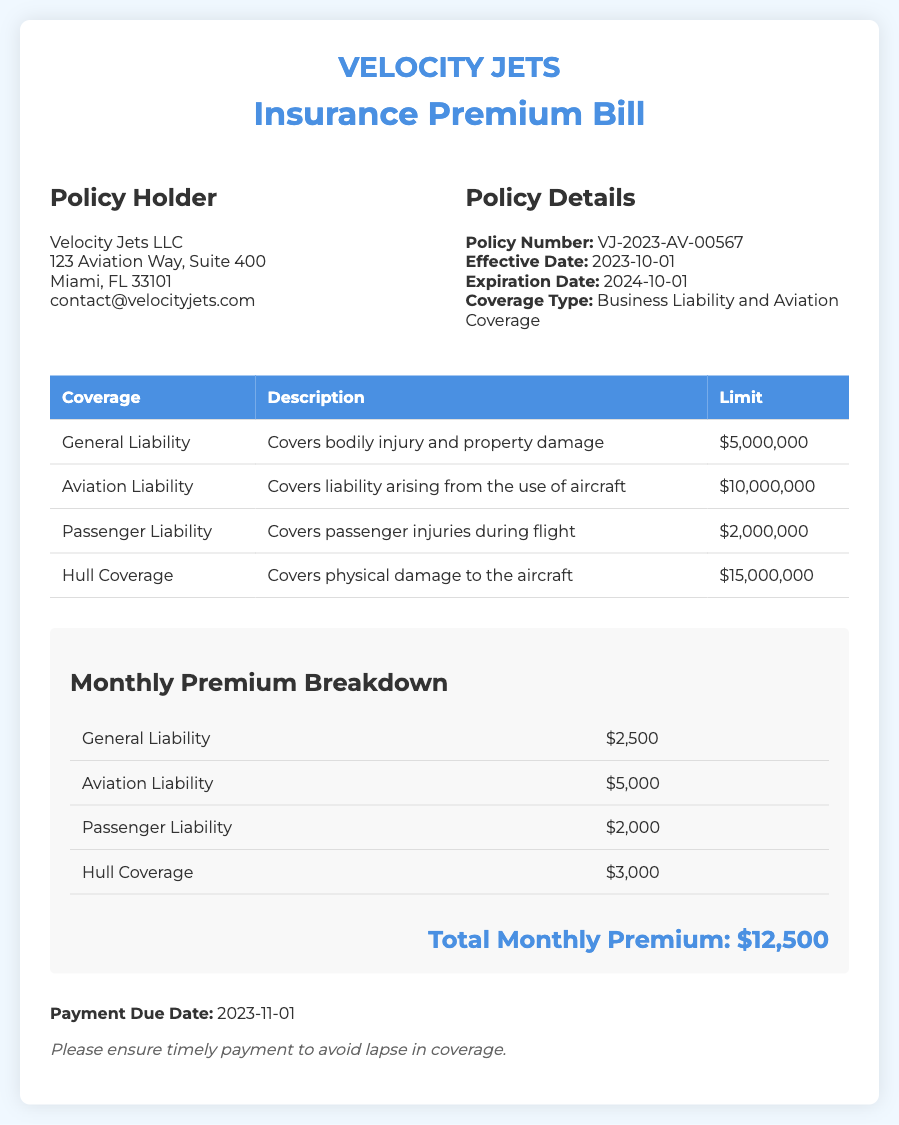What is the effective date of the policy? The effective date of the policy is specified in the document as the date when coverage starts, which is 2023-10-01.
Answer: 2023-10-01 What is the total monthly premium? The total monthly premium is calculated by summing the individual premium amounts listed, which totals to $12,500.
Answer: $12,500 What is the limit for Aviation Liability coverage? The document states that the limit for Aviation Liability coverage, which is a specific type of insurance, is explicitly mentioned as $10,000,000.
Answer: $10,000,000 What is the payment due date? The payment due date is the date by which the premium must be paid to maintain coverage, given in the document as 2023-11-01.
Answer: 2023-11-01 How much is the Hull Coverage premium? The premium amount for Hull Coverage is provided directly in the document as $3,000, indicating the cost for this specific coverage type.
Answer: $3,000 What is the expiration date of the policy? The expiration date indicates when the policy will no longer be in effect, stated in the document as 2024-10-01.
Answer: 2024-10-01 What type of coverage is included in this bill? The types of coverage included are detailed in the document, highlighting that they cover Business Liability and Aviation Coverage.
Answer: Business Liability and Aviation Coverage Which company is the policy holder? The policy holder is mentioned in the document as the entity that owns the insurance policy, which is Velocity Jets LLC.
Answer: Velocity Jets LLC What is the limit for Passenger Liability coverage? The document specifies that the limit for Passenger Liability coverage is quoted as $2,000,000, indicating the maximum amount the policy will pay for claims.
Answer: $2,000,000 